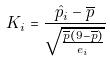<formula> <loc_0><loc_0><loc_500><loc_500>K _ { i } = \frac { \hat { p } _ { i } - \overline { p } } { \sqrt { \frac { \overline { p } ( 9 - \overline { p } ) } { e _ { i } } } }</formula> 